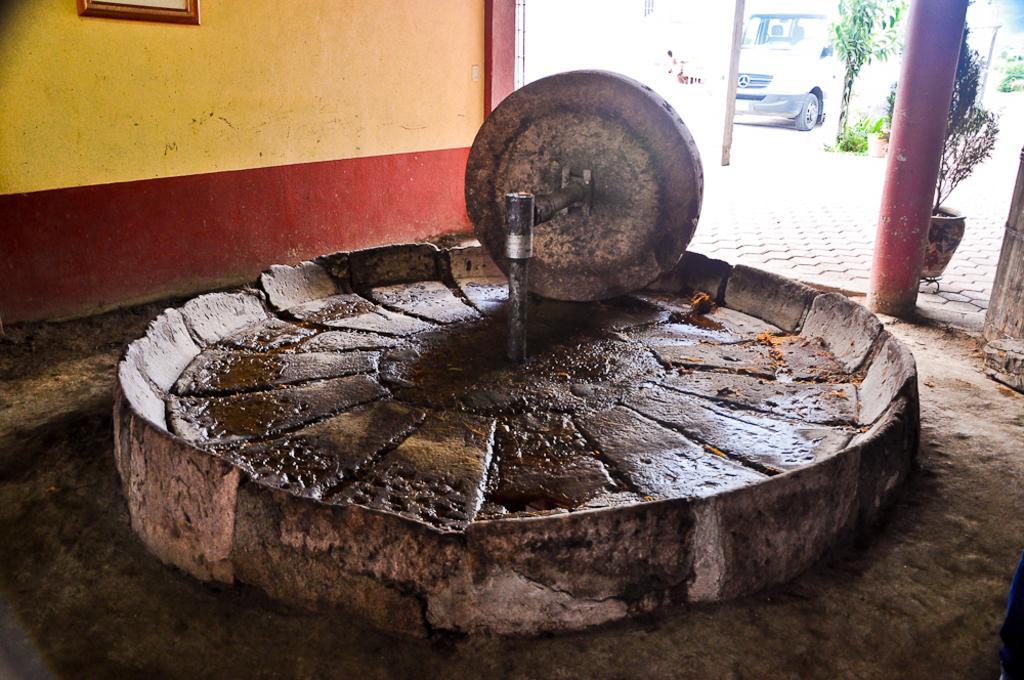Please provide a concise description of this image. In this picture we can see an object, house plants, pillar and a frame on the wall and in the background we can see a vehicle. 